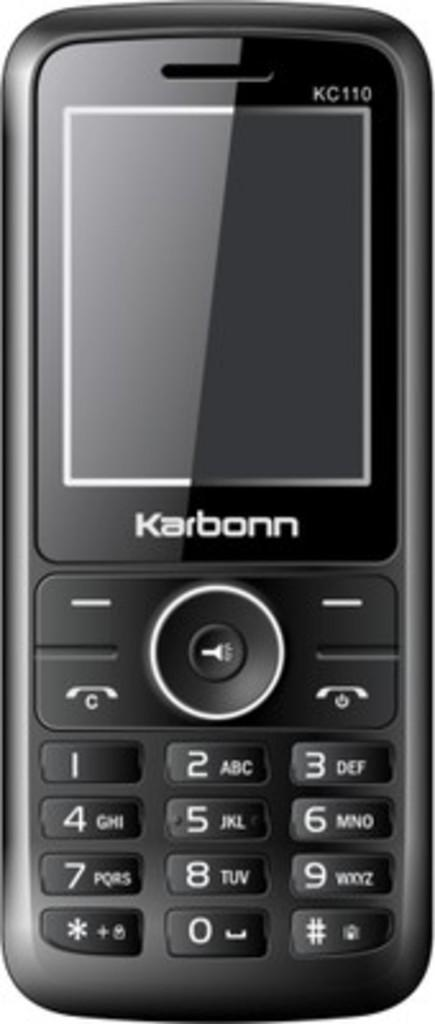<image>
Offer a succinct explanation of the picture presented. Black cellphone that is made by the brand Karbonn. 